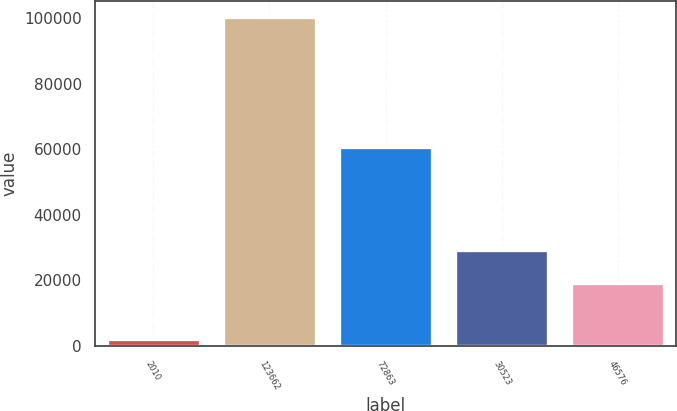<chart> <loc_0><loc_0><loc_500><loc_500><bar_chart><fcel>2010<fcel>123662<fcel>72863<fcel>30523<fcel>46576<nl><fcel>2009<fcel>100321<fcel>60610<fcel>29146.2<fcel>19315<nl></chart> 